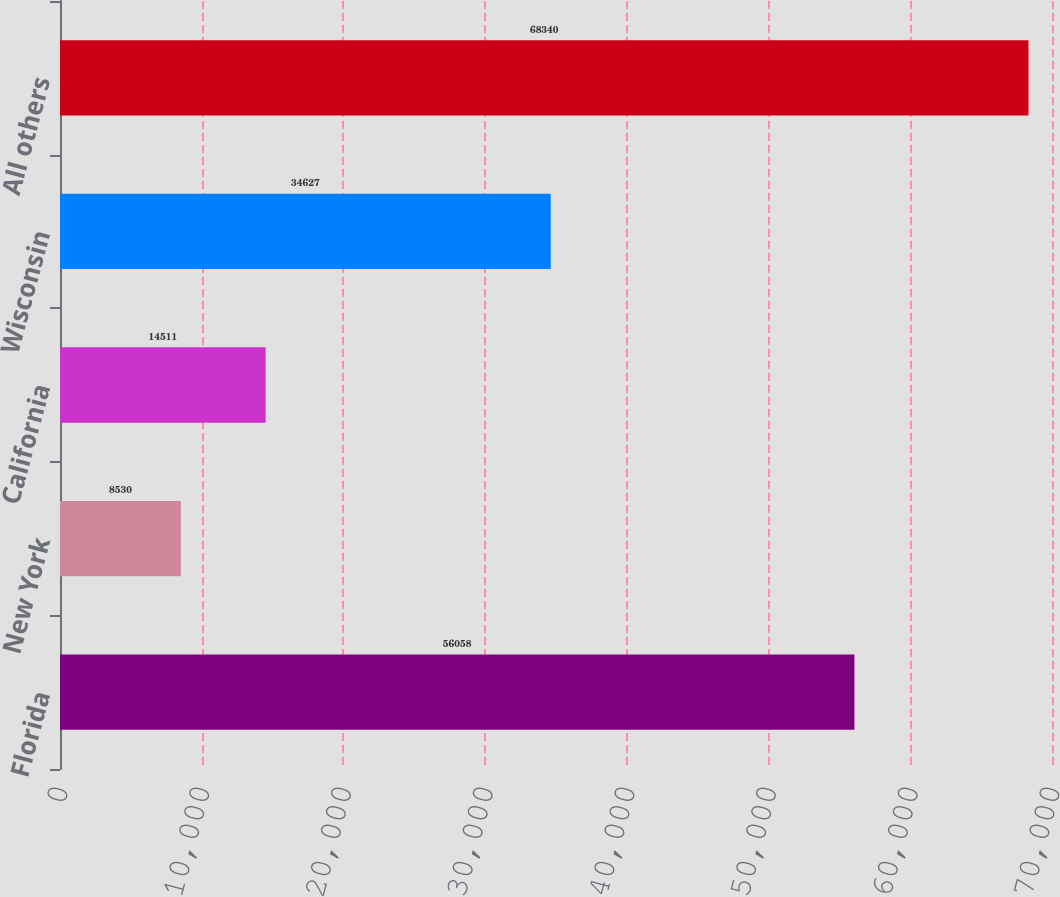<chart> <loc_0><loc_0><loc_500><loc_500><bar_chart><fcel>Florida<fcel>New York<fcel>California<fcel>Wisconsin<fcel>All others<nl><fcel>56058<fcel>8530<fcel>14511<fcel>34627<fcel>68340<nl></chart> 